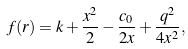<formula> <loc_0><loc_0><loc_500><loc_500>f ( r ) = k + \frac { x ^ { 2 } } { 2 } - \frac { c _ { 0 } } { 2 x } + \frac { q ^ { 2 } } { 4 x ^ { 2 } } ,</formula> 